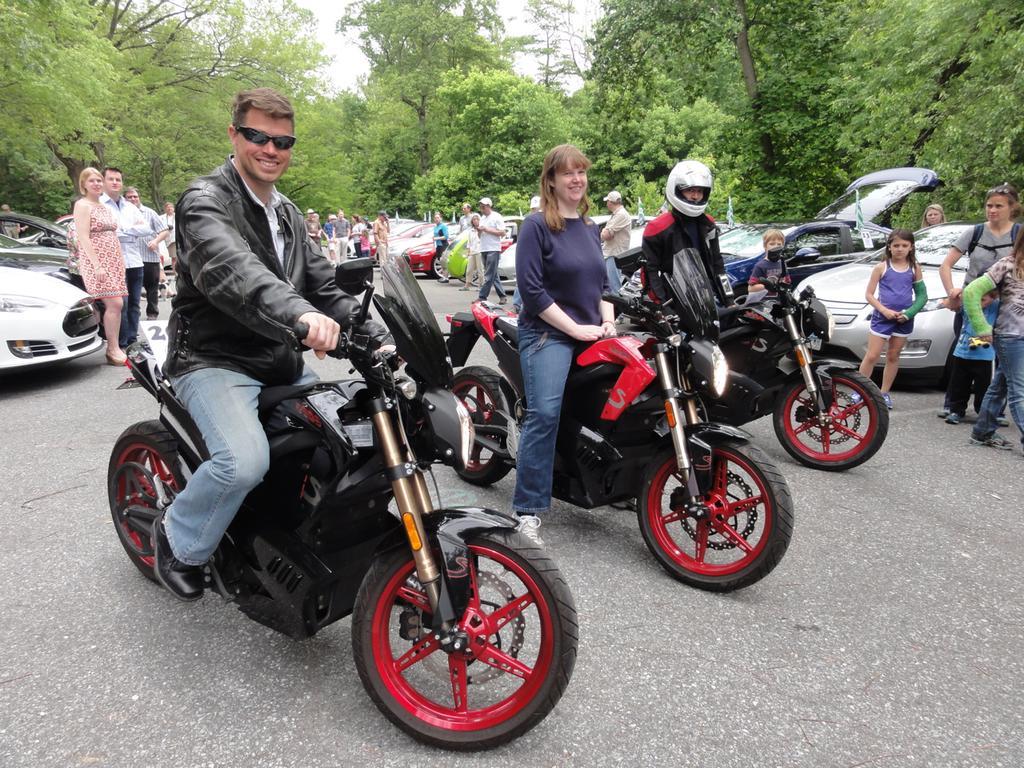Describe this image in one or two sentences. In this picture there are three people sitting on bikes. A person in the left side, he is wearing a black jacket, blue jeans and black shoe. The woman in the middle, she is wearing a purple dress and blue jeans. A person in the right, he is wearing a black jacket and white helmet. In the background there are group of people, group of cars and group of trees. 